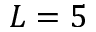Convert formula to latex. <formula><loc_0><loc_0><loc_500><loc_500>L = 5</formula> 